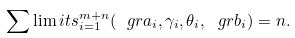Convert formula to latex. <formula><loc_0><loc_0><loc_500><loc_500>\sum \lim i t s _ { i = 1 } ^ { m + n } ( \ g r a _ { i } , \gamma _ { i } , \theta _ { i } , \ g r b _ { i } ) = n .</formula> 